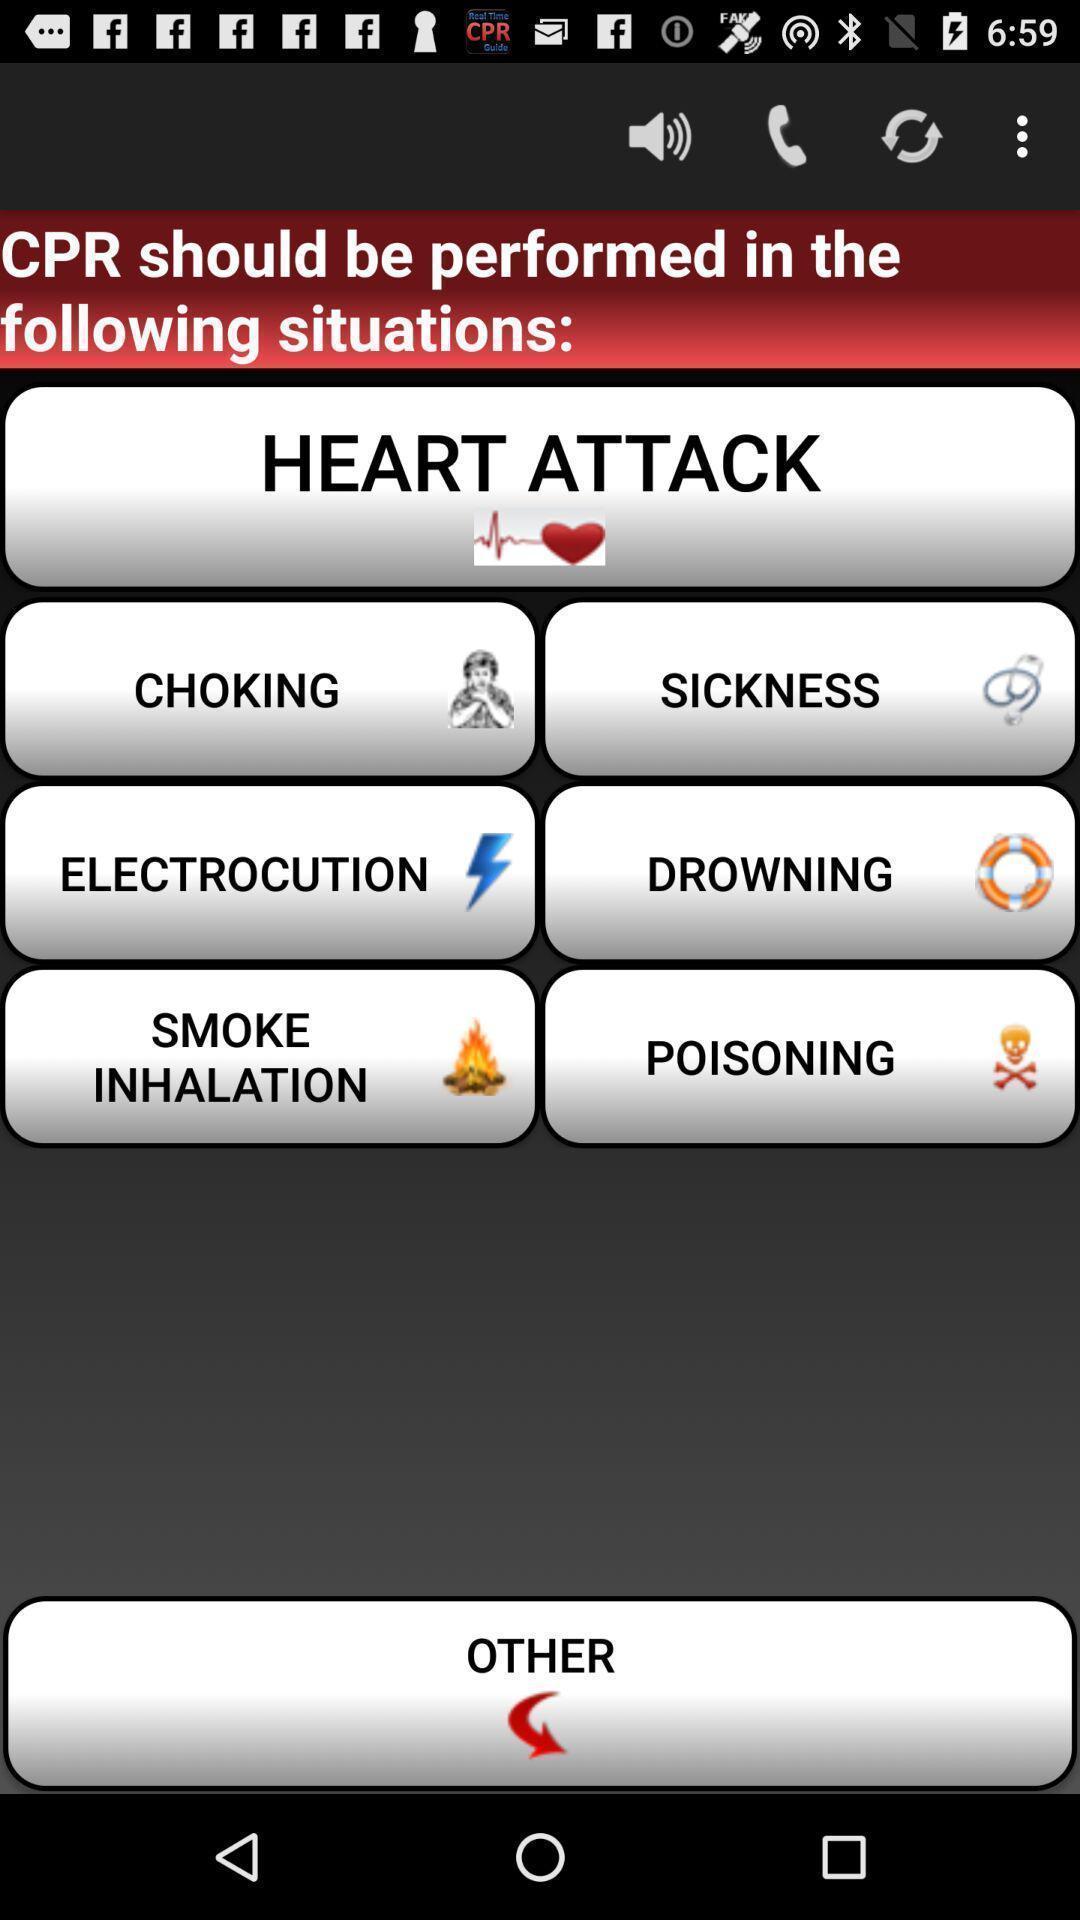Please provide a description for this image. Page showing different options like other. 